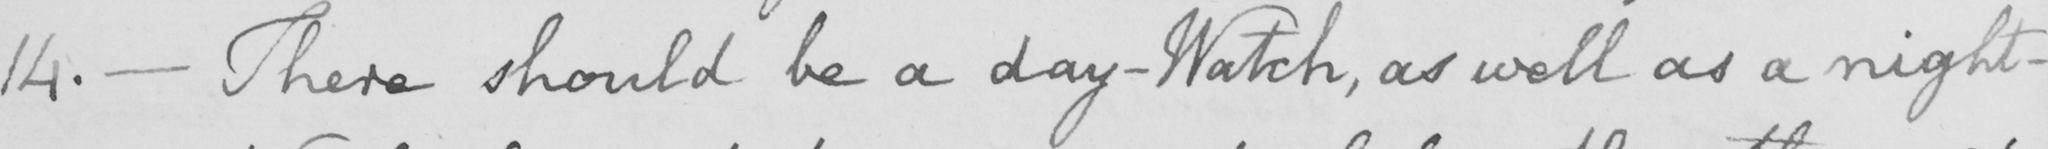Transcribe the text shown in this historical manuscript line. 14 .  _  There should be a day-Watch , as well as a night- 